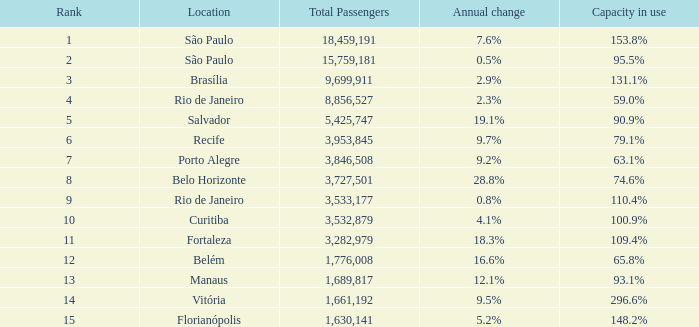What location has an annual change of 7.6% São Paulo. 